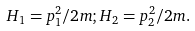Convert formula to latex. <formula><loc_0><loc_0><loc_500><loc_500>H _ { 1 } = p ^ { 2 } _ { 1 } / 2 m ; H _ { 2 } = p ^ { 2 } _ { 2 } / 2 m .</formula> 